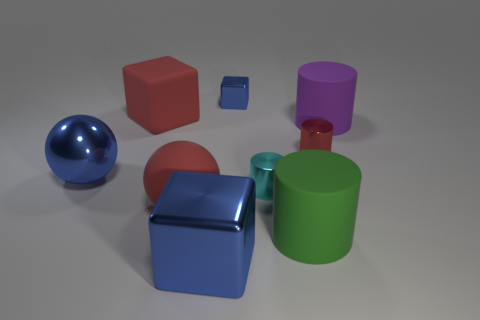Subtract all small cyan metallic cylinders. How many cylinders are left? 3 Add 1 small metallic cylinders. How many objects exist? 10 Subtract all cyan cylinders. How many cylinders are left? 3 Subtract all cubes. How many objects are left? 6 Subtract 1 balls. How many balls are left? 1 Add 6 small shiny cylinders. How many small shiny cylinders are left? 8 Add 5 blue metallic objects. How many blue metallic objects exist? 8 Subtract 1 red cubes. How many objects are left? 8 Subtract all red blocks. Subtract all gray spheres. How many blocks are left? 2 Subtract all purple spheres. How many cyan cylinders are left? 1 